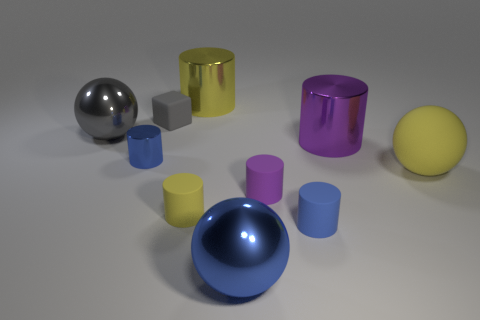Subtract all blue balls. How many balls are left? 2 Subtract 6 cylinders. How many cylinders are left? 0 Subtract all blue cylinders. How many cylinders are left? 4 Subtract all cylinders. How many objects are left? 4 Add 5 big purple metal things. How many big purple metal things are left? 6 Add 1 big metal cylinders. How many big metal cylinders exist? 3 Subtract 1 gray blocks. How many objects are left? 9 Subtract all purple balls. Subtract all red cubes. How many balls are left? 3 Subtract all brown cubes. How many red cylinders are left? 0 Subtract all big brown rubber blocks. Subtract all yellow rubber things. How many objects are left? 8 